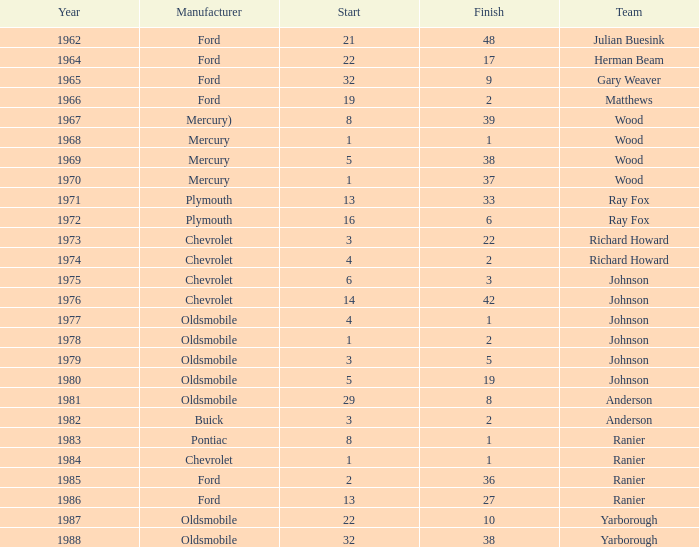In the race where cale yarborough's starting position was 19 and he completed it earlier than 42, who produced his car? Ford. 